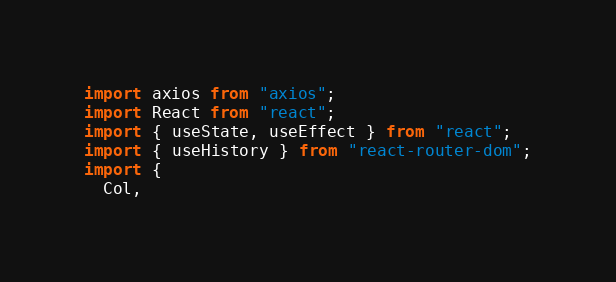<code> <loc_0><loc_0><loc_500><loc_500><_JavaScript_>import axios from "axios";
import React from "react";
import { useState, useEffect } from "react";
import { useHistory } from "react-router-dom";
import {
  Col,</code> 